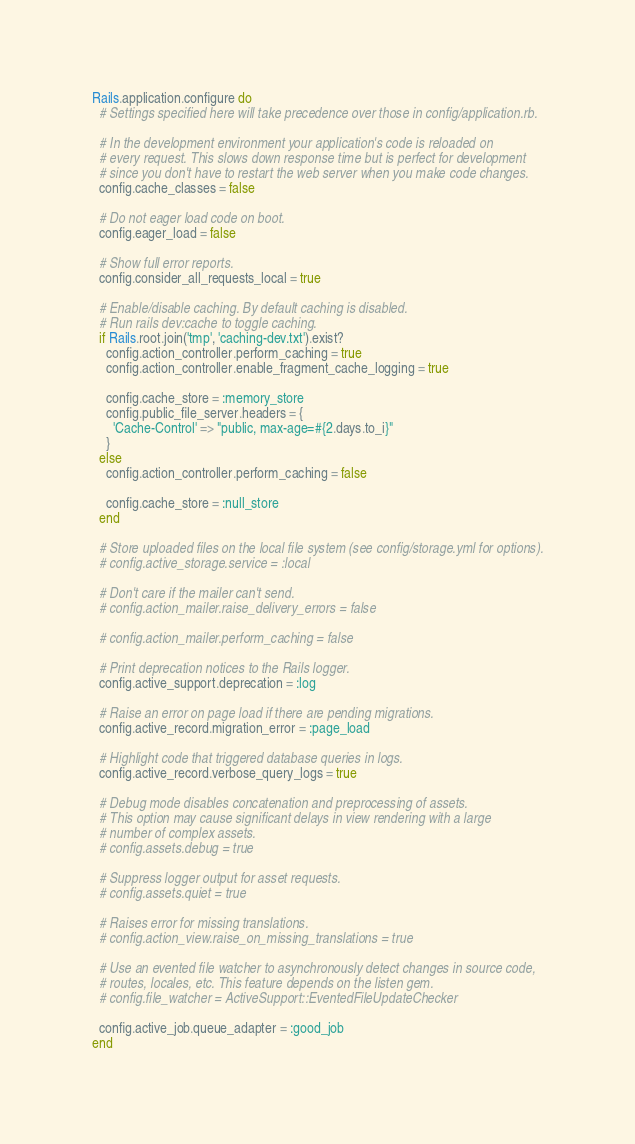Convert code to text. <code><loc_0><loc_0><loc_500><loc_500><_Ruby_>Rails.application.configure do
  # Settings specified here will take precedence over those in config/application.rb.

  # In the development environment your application's code is reloaded on
  # every request. This slows down response time but is perfect for development
  # since you don't have to restart the web server when you make code changes.
  config.cache_classes = false

  # Do not eager load code on boot.
  config.eager_load = false

  # Show full error reports.
  config.consider_all_requests_local = true

  # Enable/disable caching. By default caching is disabled.
  # Run rails dev:cache to toggle caching.
  if Rails.root.join('tmp', 'caching-dev.txt').exist?
    config.action_controller.perform_caching = true
    config.action_controller.enable_fragment_cache_logging = true

    config.cache_store = :memory_store
    config.public_file_server.headers = {
      'Cache-Control' => "public, max-age=#{2.days.to_i}"
    }
  else
    config.action_controller.perform_caching = false

    config.cache_store = :null_store
  end

  # Store uploaded files on the local file system (see config/storage.yml for options).
  # config.active_storage.service = :local

  # Don't care if the mailer can't send.
  # config.action_mailer.raise_delivery_errors = false

  # config.action_mailer.perform_caching = false

  # Print deprecation notices to the Rails logger.
  config.active_support.deprecation = :log

  # Raise an error on page load if there are pending migrations.
  config.active_record.migration_error = :page_load

  # Highlight code that triggered database queries in logs.
  config.active_record.verbose_query_logs = true

  # Debug mode disables concatenation and preprocessing of assets.
  # This option may cause significant delays in view rendering with a large
  # number of complex assets.
  # config.assets.debug = true

  # Suppress logger output for asset requests.
  # config.assets.quiet = true

  # Raises error for missing translations.
  # config.action_view.raise_on_missing_translations = true

  # Use an evented file watcher to asynchronously detect changes in source code,
  # routes, locales, etc. This feature depends on the listen gem.
  # config.file_watcher = ActiveSupport::EventedFileUpdateChecker

  config.active_job.queue_adapter = :good_job
end
</code> 